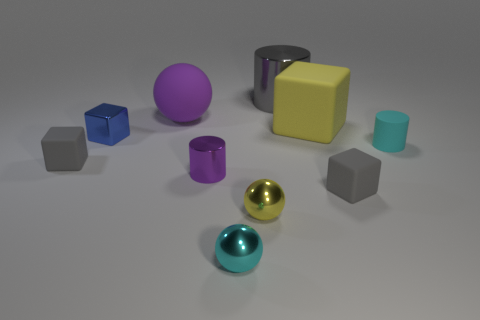Subtract all cubes. How many objects are left? 6 Subtract all small blue cubes. Subtract all small rubber objects. How many objects are left? 6 Add 5 small purple shiny objects. How many small purple shiny objects are left? 6 Add 2 blue matte cylinders. How many blue matte cylinders exist? 2 Subtract 0 gray spheres. How many objects are left? 10 